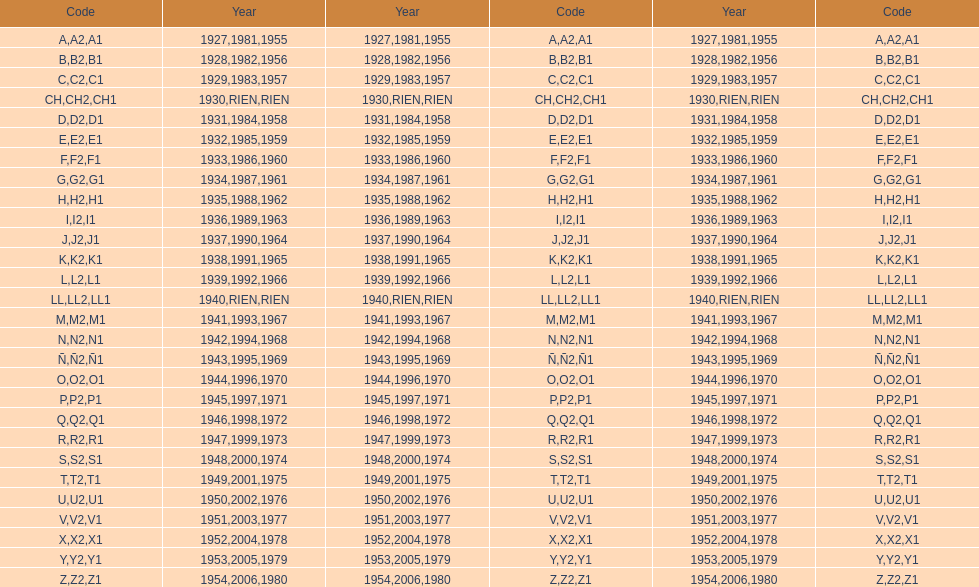What was the lowest year stamped? 1927. 